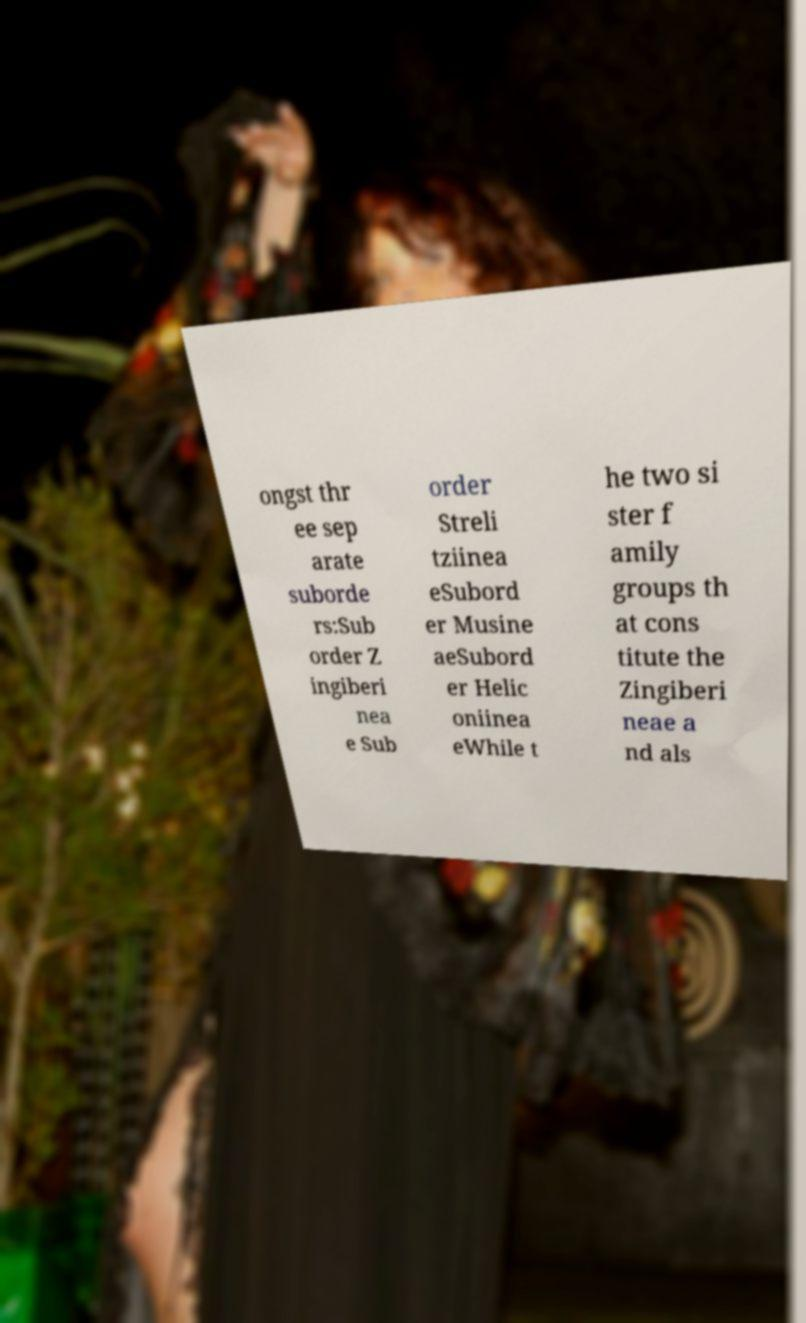There's text embedded in this image that I need extracted. Can you transcribe it verbatim? ongst thr ee sep arate suborde rs:Sub order Z ingiberi nea e Sub order Streli tziinea eSubord er Musine aeSubord er Helic oniinea eWhile t he two si ster f amily groups th at cons titute the Zingiberi neae a nd als 